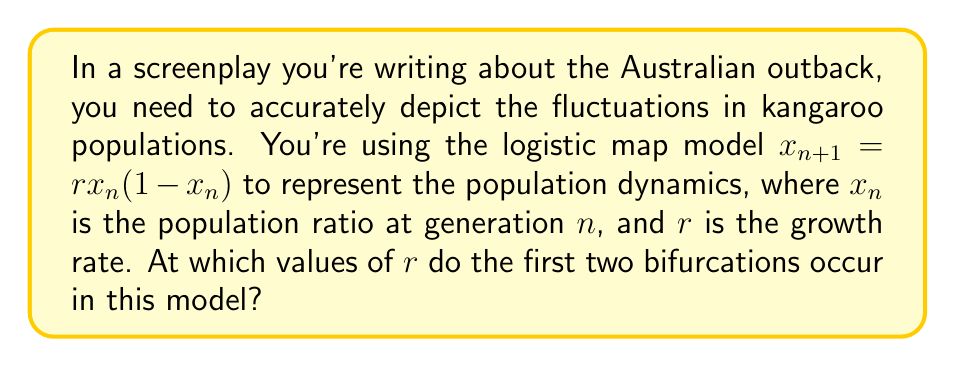Could you help me with this problem? Let's approach this step-by-step:

1) The logistic map is given by the equation $x_{n+1} = rx_n(1-x_n)$, where $r$ is the growth rate parameter.

2) Bifurcations occur when the stability of fixed points changes. We need to find these fixed points first.

3) At a fixed point, $x_{n+1} = x_n = x^*$. So, we solve:
   $x^* = rx^*(1-x^*)$

4) This gives us two solutions:
   $x^* = 0$ and $x^* = 1 - \frac{1}{r}$

5) The stability of these fixed points changes when $|\frac{d}{dx}(rx(1-x))| = 1$ at $x^*$

6) For the non-zero fixed point $x^* = 1 - \frac{1}{r}$:
   $|\frac{d}{dx}(rx(1-x))| = |r(1-2x^*)| = |2-r| = 1$

7) Solving this, we get $r = 3$ for the first bifurcation.

8) The second bifurcation occurs when the period-2 cycle becomes unstable. This happens when:
   $|\frac{d}{dx}(r^2x(1-x)(1-rx(1-x)))| = 1$ at the period-2 points.

9) Solving this equation numerically gives us $r \approx 3.449489742783178$

These are the values of $r$ at which the first two bifurcations occur in the logistic map model.
Answer: $r_1 = 3$, $r_2 \approx 3.449489742783178$ 